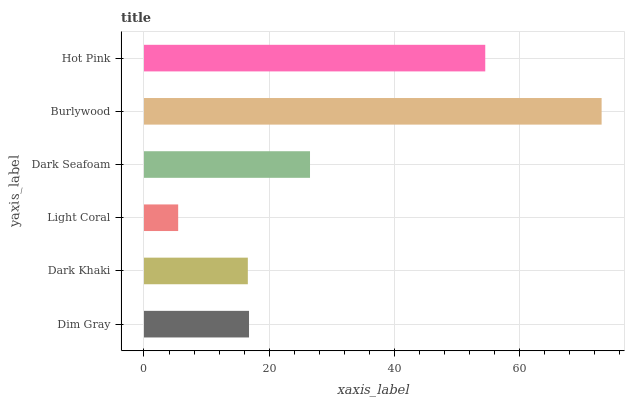Is Light Coral the minimum?
Answer yes or no. Yes. Is Burlywood the maximum?
Answer yes or no. Yes. Is Dark Khaki the minimum?
Answer yes or no. No. Is Dark Khaki the maximum?
Answer yes or no. No. Is Dim Gray greater than Dark Khaki?
Answer yes or no. Yes. Is Dark Khaki less than Dim Gray?
Answer yes or no. Yes. Is Dark Khaki greater than Dim Gray?
Answer yes or no. No. Is Dim Gray less than Dark Khaki?
Answer yes or no. No. Is Dark Seafoam the high median?
Answer yes or no. Yes. Is Dim Gray the low median?
Answer yes or no. Yes. Is Dark Khaki the high median?
Answer yes or no. No. Is Hot Pink the low median?
Answer yes or no. No. 